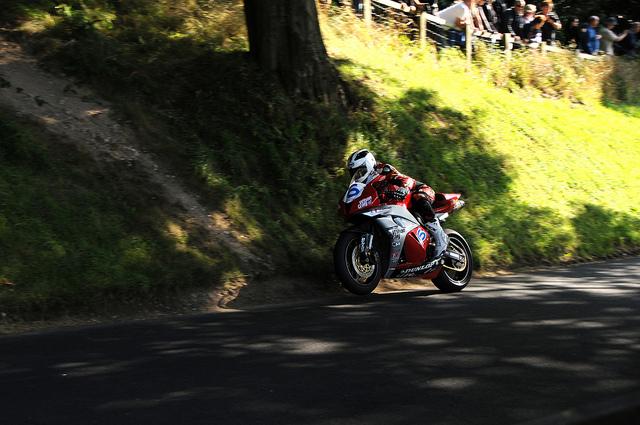Are there spectators?
Quick response, please. Yes. What color is the helmet on the left?
Answer briefly. White. Are there any vegetation?
Answer briefly. Yes. Is the motorcycle in motion?
Short answer required. Yes. 